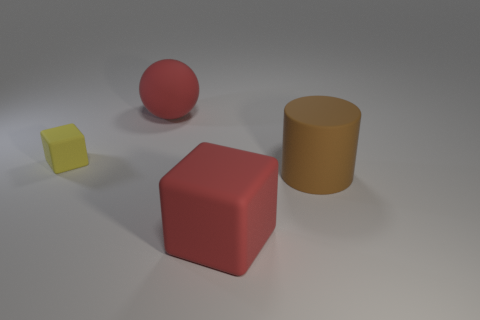Add 2 yellow things. How many objects exist? 6 Subtract 0 gray cubes. How many objects are left? 4 Subtract all large rubber cubes. Subtract all large red cubes. How many objects are left? 2 Add 2 large objects. How many large objects are left? 5 Add 4 large red things. How many large red things exist? 6 